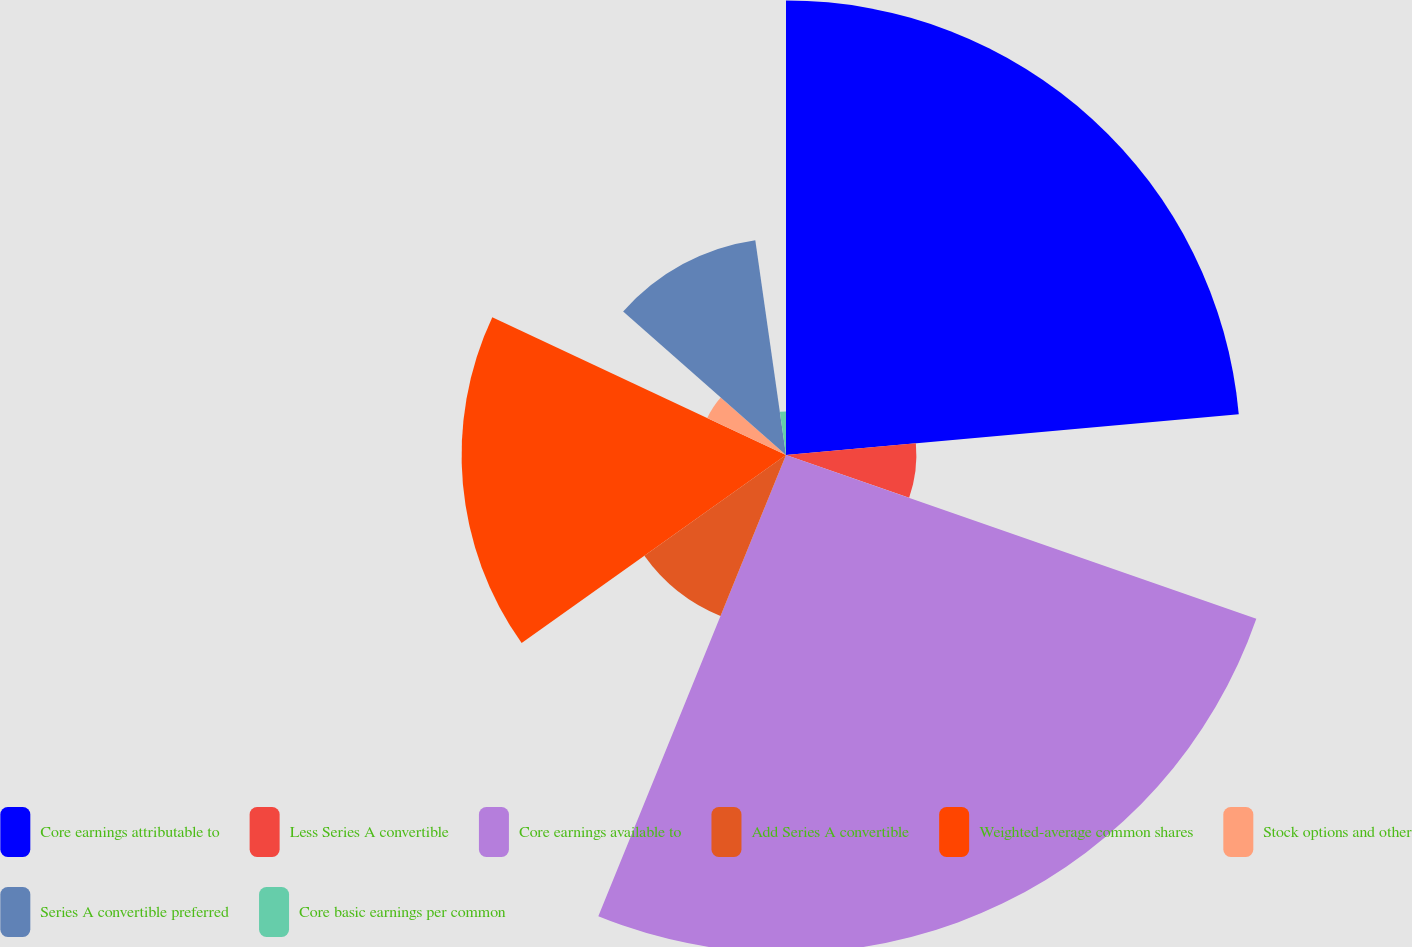Convert chart. <chart><loc_0><loc_0><loc_500><loc_500><pie_chart><fcel>Core earnings attributable to<fcel>Less Series A convertible<fcel>Core earnings available to<fcel>Add Series A convertible<fcel>Weighted-average common shares<fcel>Stock options and other<fcel>Series A convertible preferred<fcel>Core basic earnings per common<nl><fcel>23.57%<fcel>6.76%<fcel>25.82%<fcel>9.01%<fcel>16.82%<fcel>4.51%<fcel>11.25%<fcel>2.26%<nl></chart> 